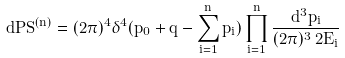<formula> <loc_0><loc_0><loc_500><loc_500>d P S ^ { ( n ) } = ( 2 \pi ) ^ { 4 } \delta ^ { 4 } ( p _ { 0 } + q - \sum _ { i = 1 } ^ { n } p _ { i } ) \prod _ { i = 1 } ^ { n } \frac { d ^ { 3 } p _ { i } } { ( 2 \pi ) ^ { 3 } \, 2 E _ { i } }</formula> 